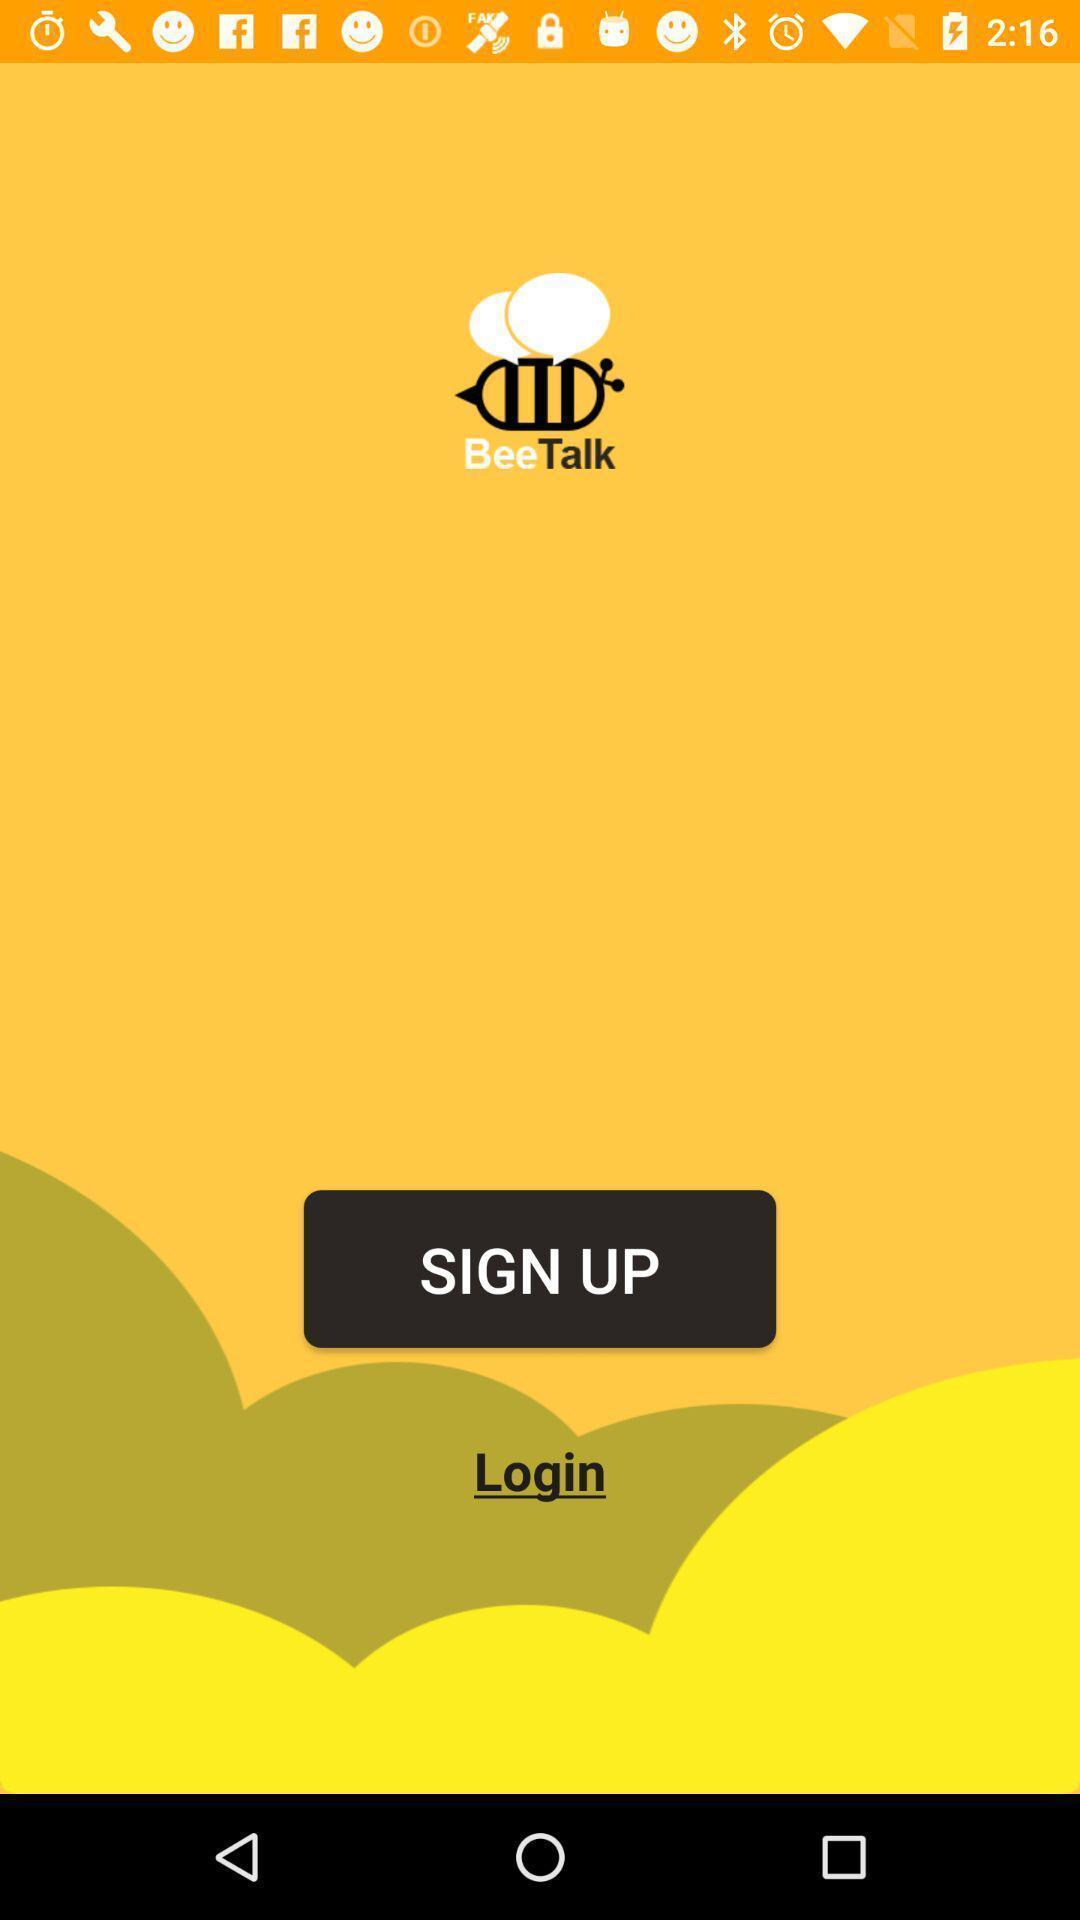Provide a detailed account of this screenshot. Sign up page to get the access form the app. 